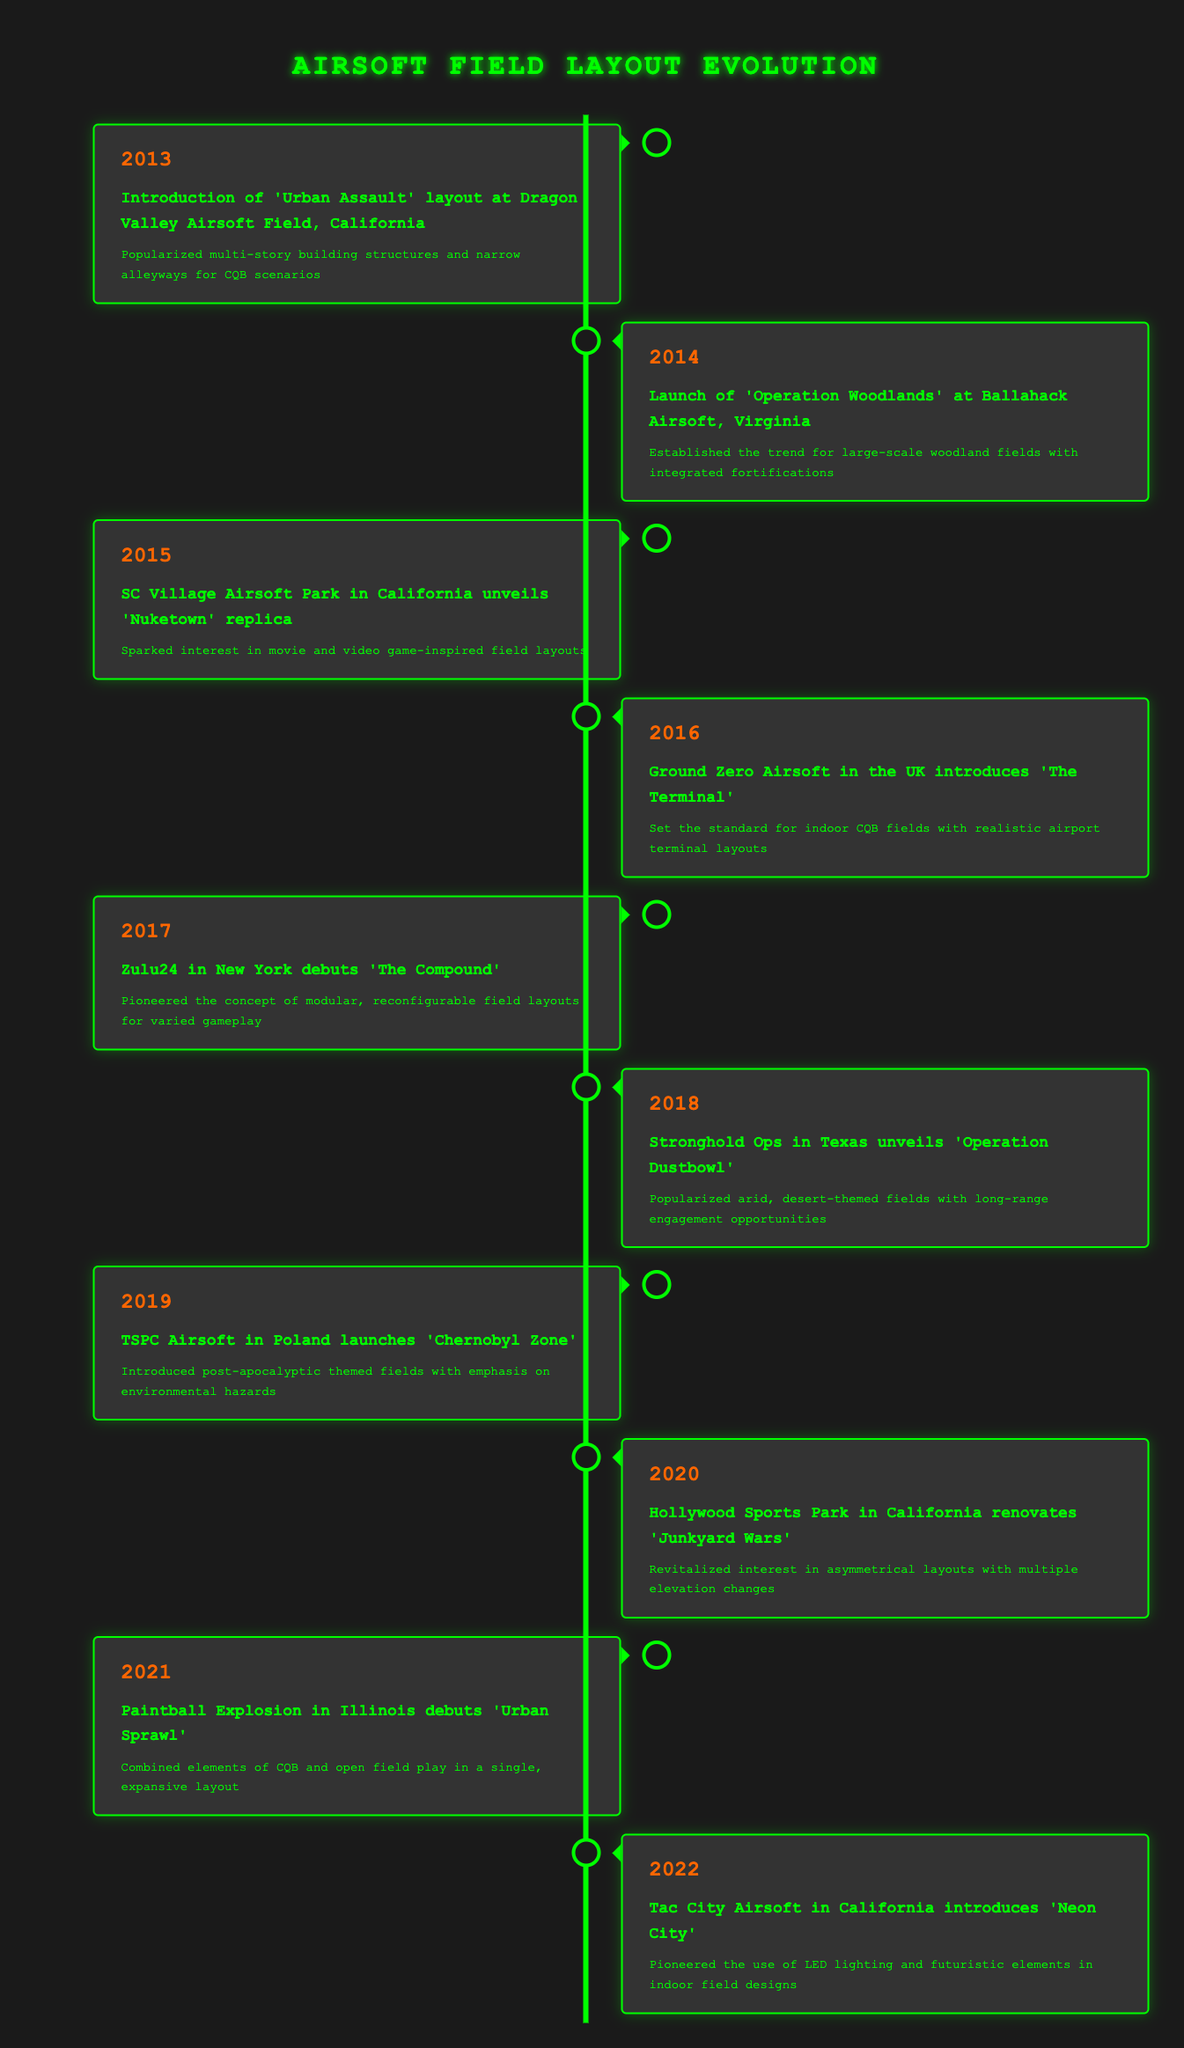What year was the 'Urban Assault' layout introduced? The 'Urban Assault' layout was introduced in 2013, as mentioned in the first row of the table.
Answer: 2013 What event occurred in 2018? In 2018, Stronghold Ops in Texas unveiled 'Operation Dustbowl', as detailed in the sixth row of the table.
Answer: Stronghold Ops in Texas unveils 'Operation Dustbowl' How many airsoft fields introduced new layouts between 2015 and 2020? The fields that introduced new layouts in that timeframe are SC Village Airsoft Park (2015), Ground Zero Airsoft (2016), Zulu24 (2017), Stronghold Ops (2018), and Hollywood Sports Park (2020), totaling 5 fields.
Answer: 5 Did any airsoft fields introduce layouts with indoor themes? Yes, Ground Zero Airsoft introduced 'The Terminal' in 2016, and Tac City Airsoft introduced 'Neon City' in 2022, both featuring indoor layouts, making the statement true.
Answer: Yes Which layout was the first to integrate modular, reconfigurable designs? The layout 'The Compound' introduced by Zulu24 in New York in 2017 was the first to integrate modular, reconfigurable designs as stated in that row of the table.
Answer: The Compound What is the average year of introduction for these layouts? The average year is calculated by adding all years from the table (2013 + 2014 + 2015 + 2016 + 2017 + 2018 + 2019 + 2020 + 2021 + 2022 = 20205), and then dividing by the number of entries (10): 20205/10 = 2020.5. Thus, the average is between 2020 and 2021, indicating it trends toward the more recent years.
Answer: 2020.5 Which field was associated with the post-apocalyptic theme? The 'Chernobyl Zone' layout launched by TSPC Airsoft in Poland in 2019 is associated with the post-apocalyptic theme, as described in that row.
Answer: Chernobyl Zone What kind of lighting was introduced in 'Neon City'? 'Neon City' pioneered the use of LED lighting, which is specifically noted in the description for Tac City Airsoft's layout introduced in 2022.
Answer: LED lighting What layout emphasizes long-range engagements in an arid setting? 'Operation Dustbowl' introduced by Stronghold Ops in Texas in 2018 emphasizes long-range engagements in an arid desert theme, as noted in that entry.
Answer: Operation Dustbowl 